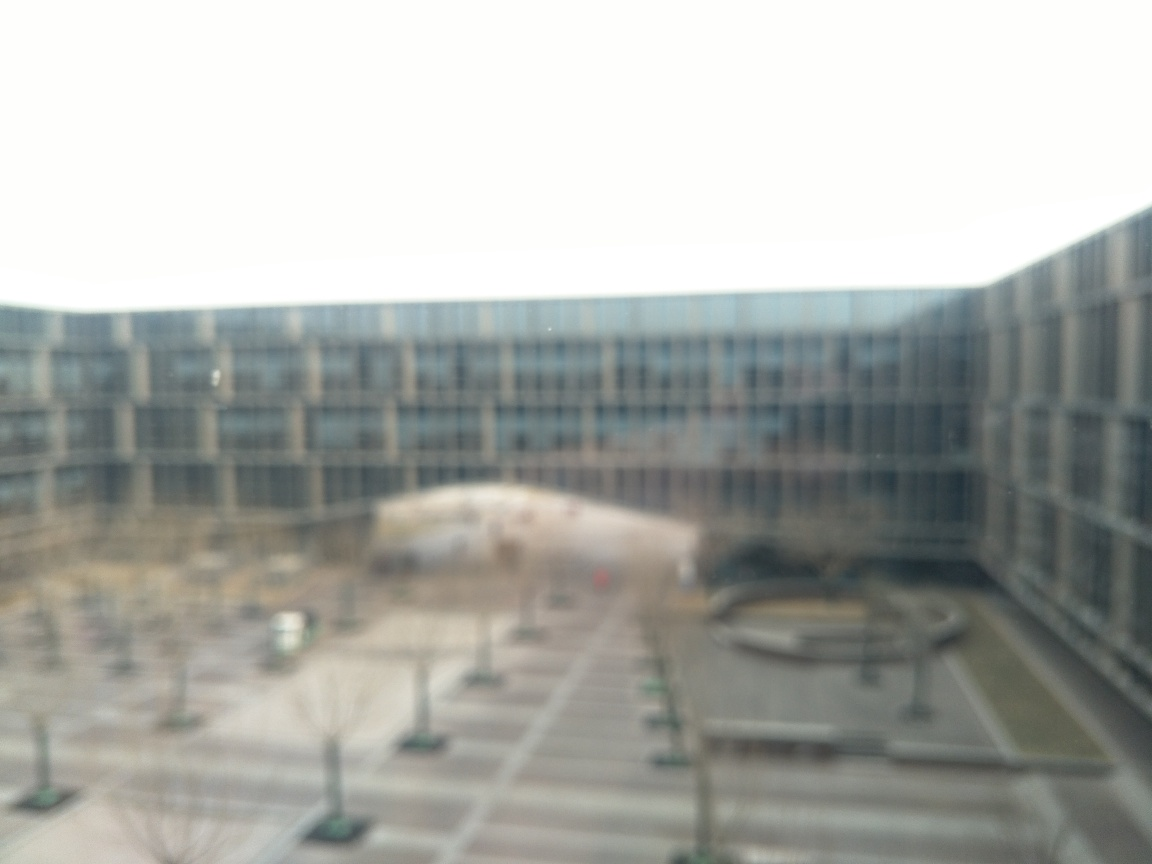Can you describe the setting or location? Certainly, despite the lack of sharpness, the setting appears to be an expansive outdoor courtyard surrounded by a large, multi-story building with numerous windows. The courtyard has a symmetrical layout with neatly arranged trees and what seems to be a fountain or sculpture at the center, suggestive of a corporate or institutional setting. 